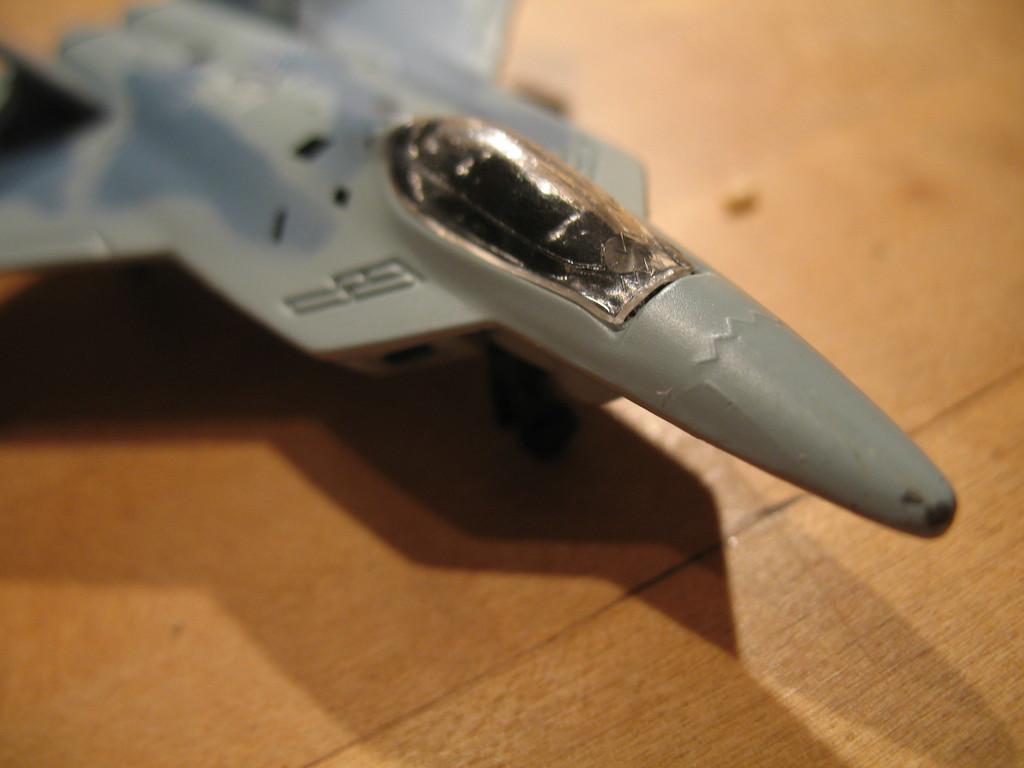Please provide a concise description of this image. In this image, we can see an aircraft toy on the surface. 